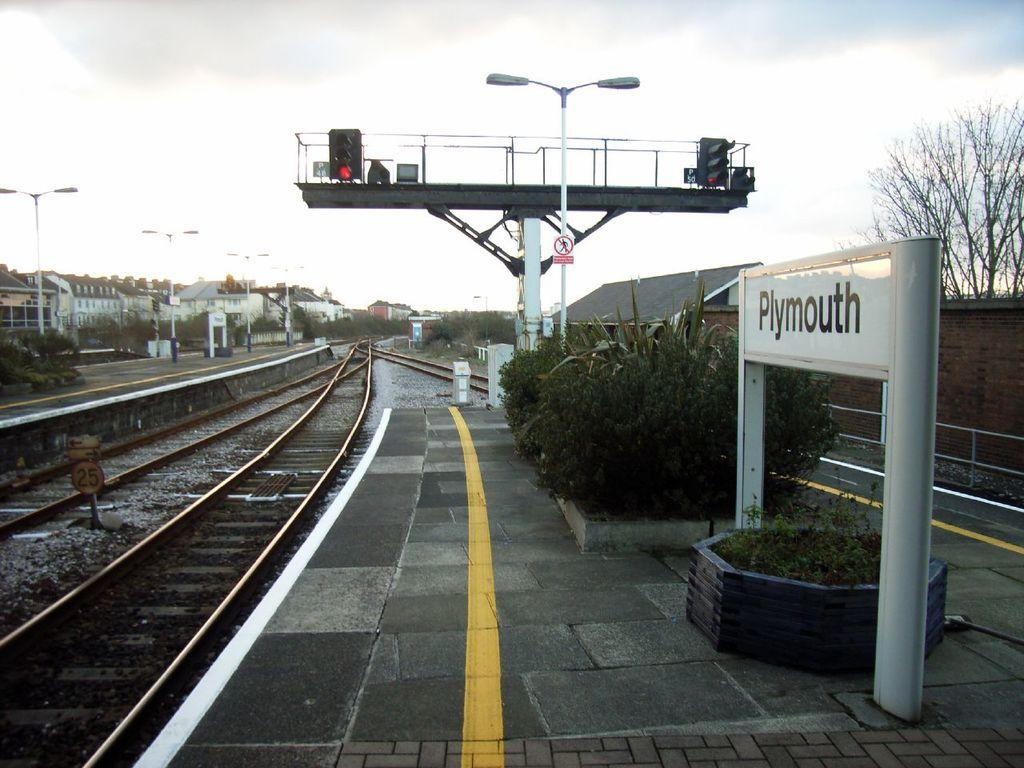What type of transportation infrastructure is visible in the image? There are railway tracks in the image. What can be seen to regulate traffic in the image? There are traffic signals in the image. What type of vegetation is present in the image? There are plants in the image. What type of structures are visible in the image? There are buildings in the image. What type of lighting is present in the image? There are street lights in the image. Where are the sign boards located in the image? The sign boards are on the left side of the image. How would you describe the weather in the image? The sky is cloudy in the image. Can you see a worm crawling on the sign board in the image? There is no worm present on the sign board or anywhere else in the image. Is the hot temperature affecting the plants in the image? The provided facts do not mention the temperature, so we cannot determine if the plants are affected by heat. 